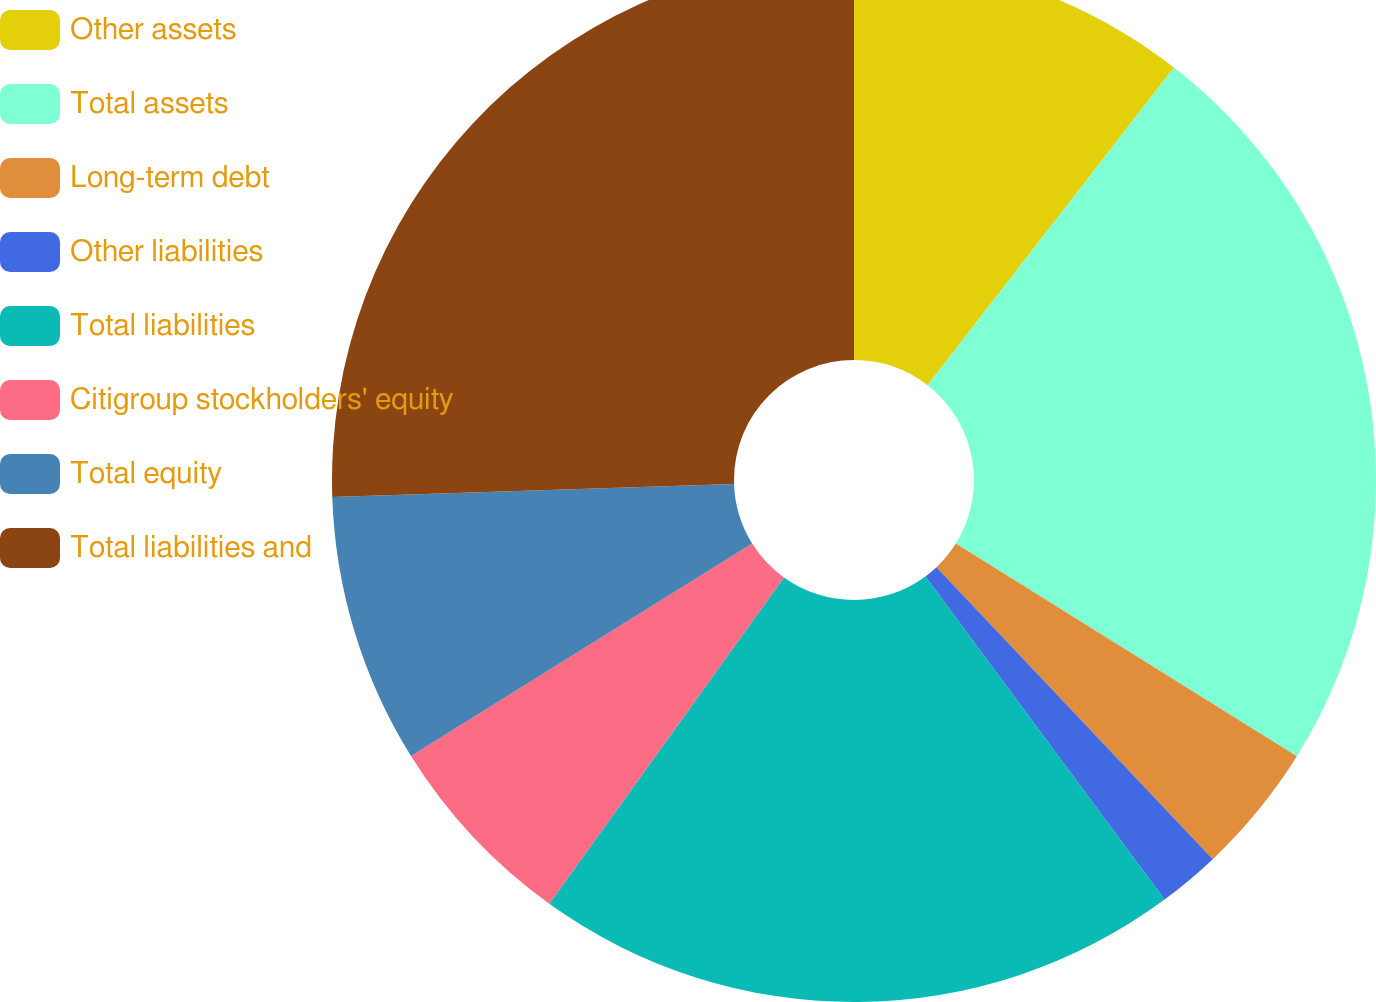<chart> <loc_0><loc_0><loc_500><loc_500><pie_chart><fcel>Other assets<fcel>Total assets<fcel>Long-term debt<fcel>Other liabilities<fcel>Total liabilities<fcel>Citigroup stockholders' equity<fcel>Total equity<fcel>Total liabilities and<nl><fcel>10.5%<fcel>23.38%<fcel>4.06%<fcel>1.92%<fcel>20.06%<fcel>6.21%<fcel>8.35%<fcel>25.52%<nl></chart> 